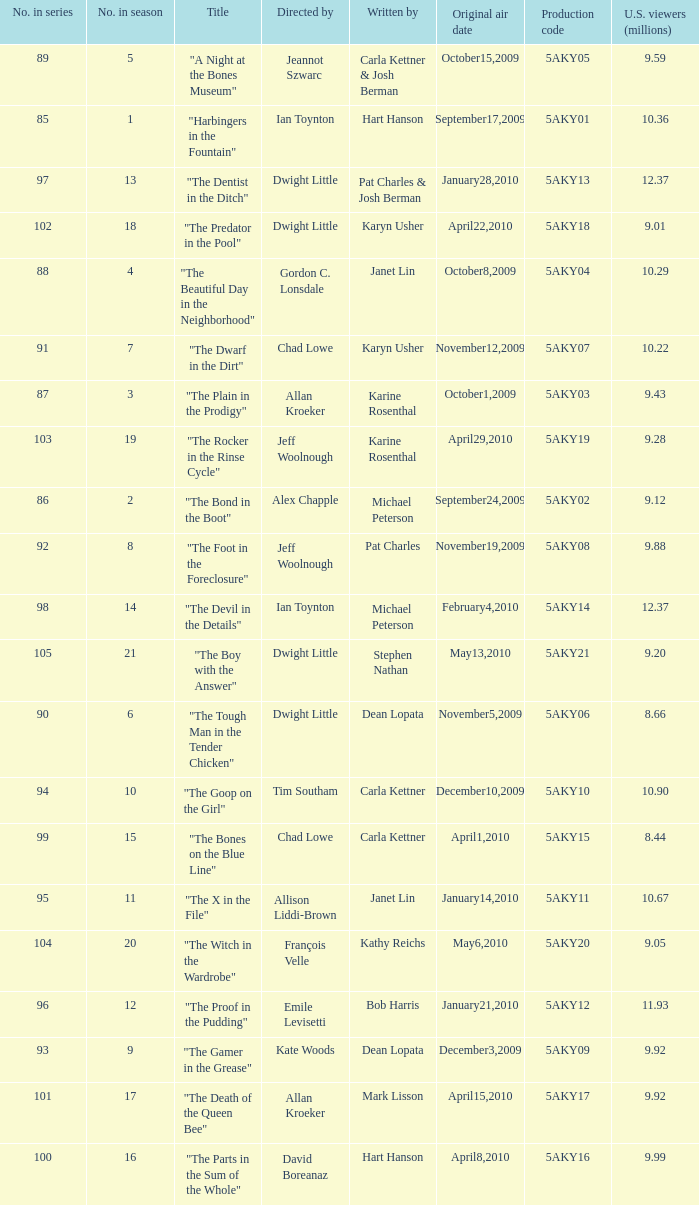Who was the writer of the episode with a production code of 5aky04? Janet Lin. 